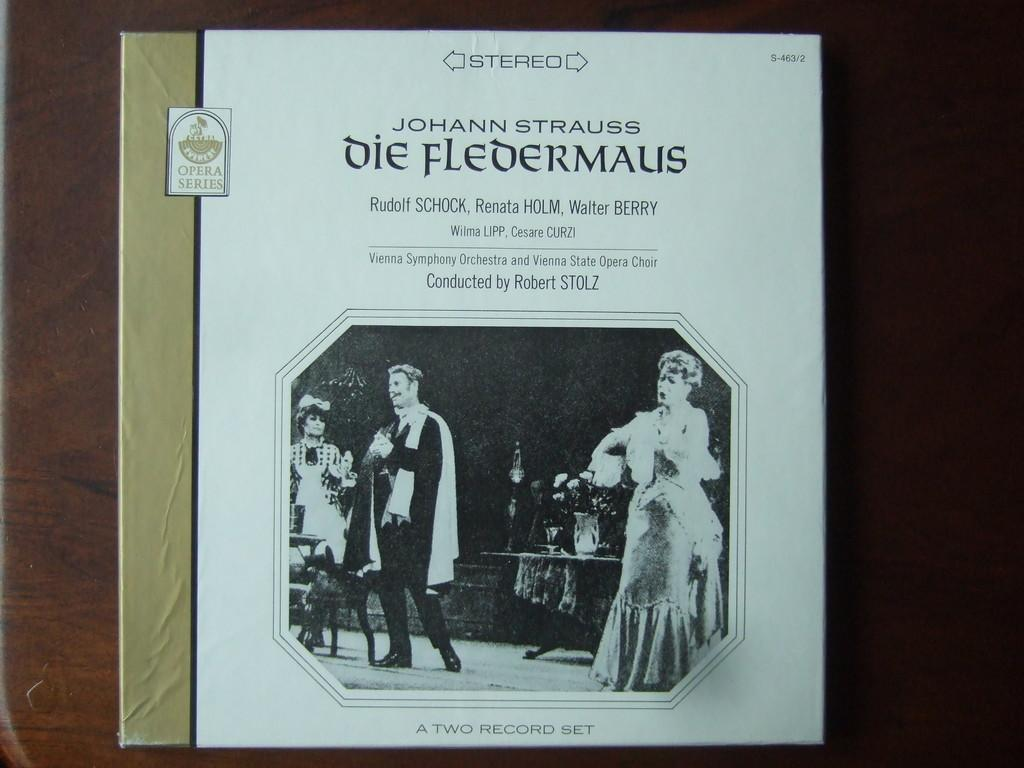Provide a one-sentence caption for the provided image. Johann Strauss Die Fledermalis book from the Opera series. 